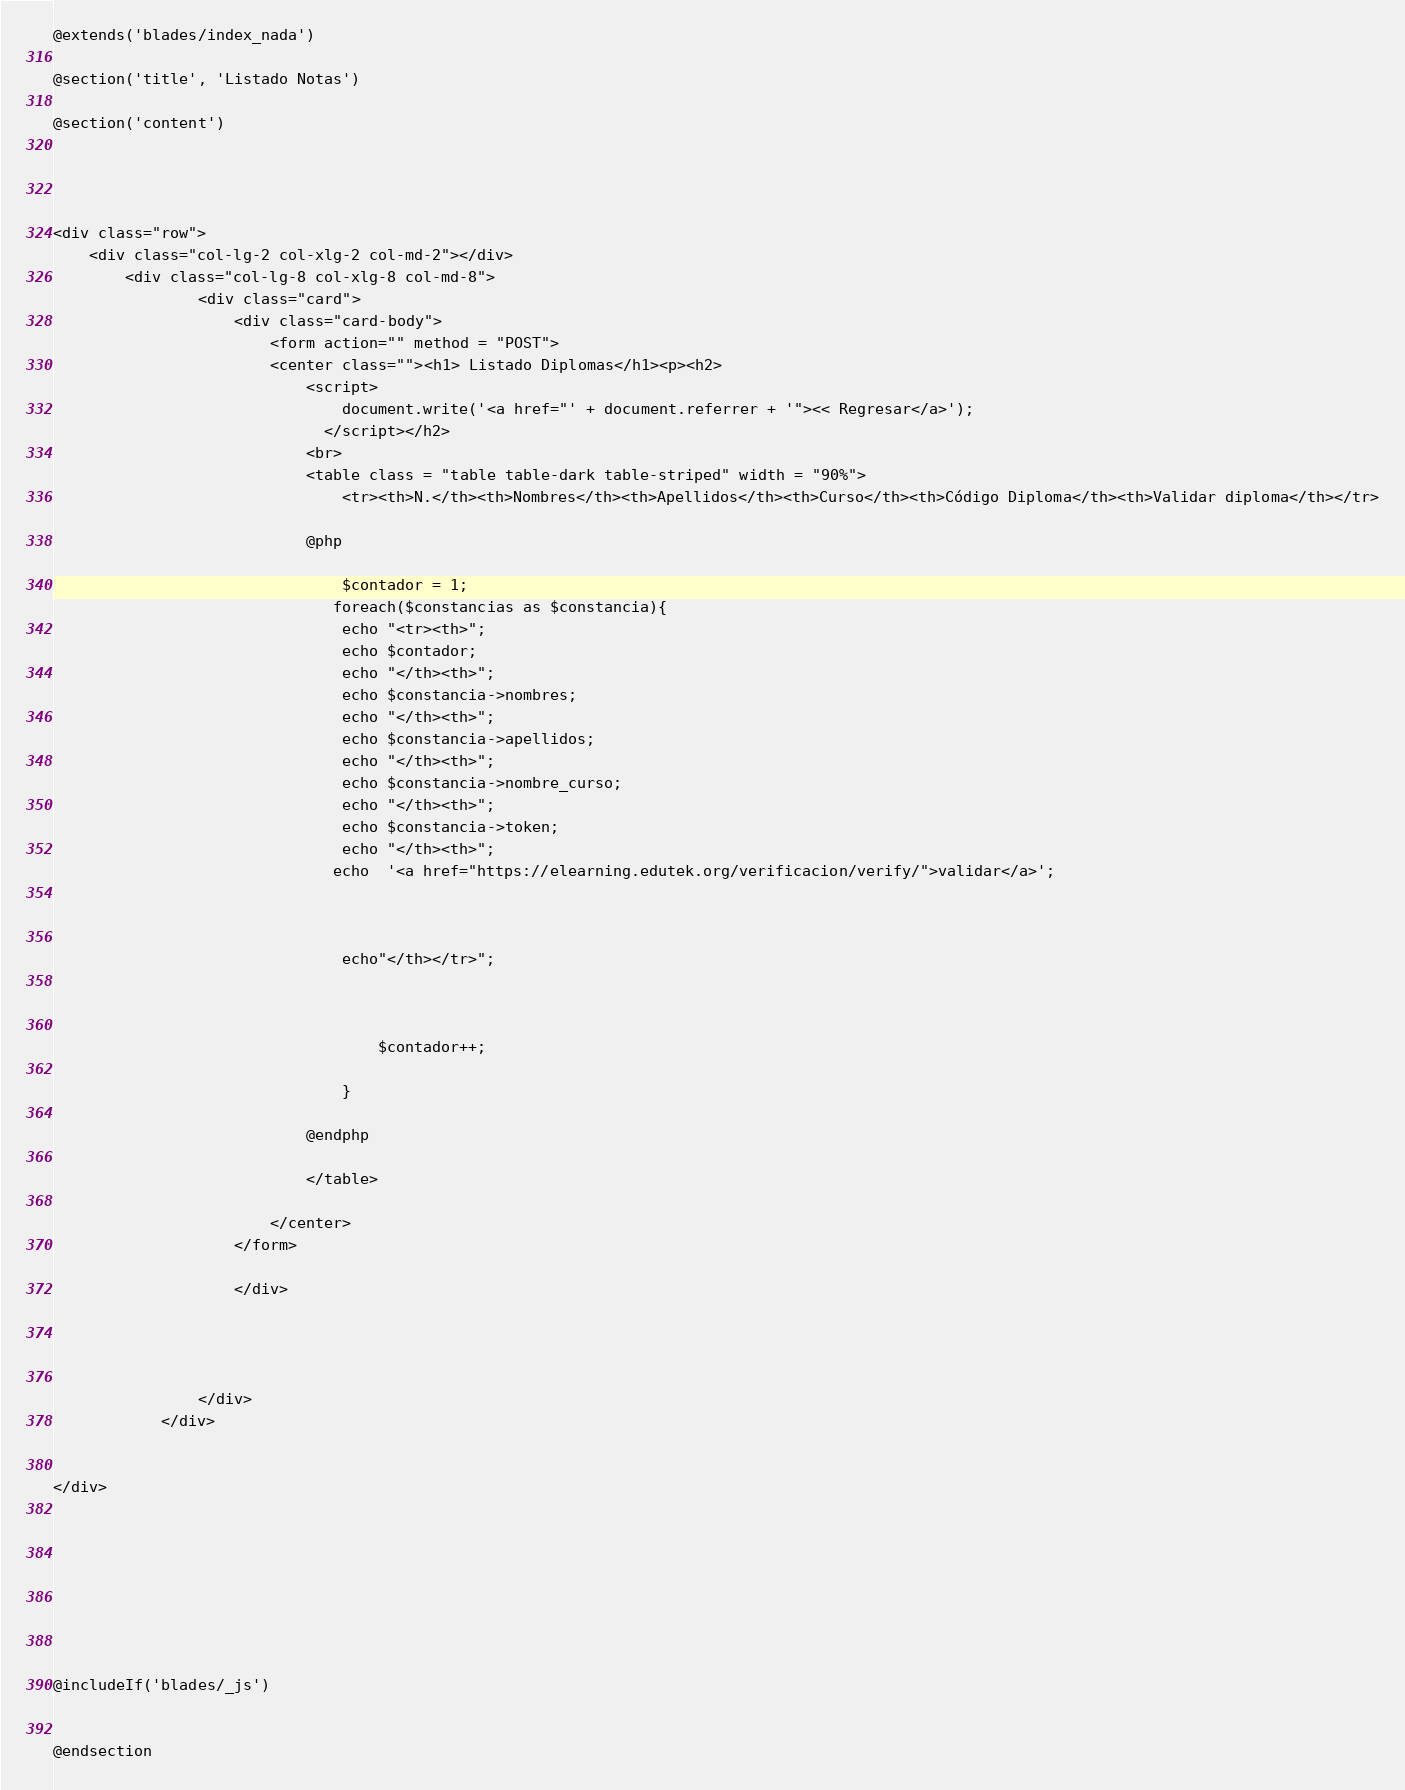Convert code to text. <code><loc_0><loc_0><loc_500><loc_500><_PHP_>@extends('blades/index_nada')

@section('title', 'Listado Notas')

@section('content')




<div class="row">
    <div class="col-lg-2 col-xlg-2 col-md-2"></div>
        <div class="col-lg-8 col-xlg-8 col-md-8">
                <div class="card">
                    <div class="card-body">
                        <form action="" method = "POST">
                        <center class=""><h1> Listado Diplomas</h1><p><h2>
                            <script>
                                document.write('<a href="' + document.referrer + '"><< Regresar</a>');
                              </script></h2>
                            <br>
                            <table class = "table table-dark table-striped" width = "90%">
                                <tr><th>N.</th><th>Nombres</th><th>Apellidos</th><th>Curso</th><th>Código Diploma</th><th>Validar diploma</th></tr>
                             
                            @php
                               
                                $contador = 1;
                               foreach($constancias as $constancia){
                                echo "<tr><th>";      
                                echo $contador;
                                echo "</th><th>";   
                                echo $constancia->nombres;
                                echo "</th><th>";
                                echo $constancia->apellidos;
                                echo "</th><th>";
                                echo $constancia->nombre_curso;
                                echo "</th><th>";
                                echo $constancia->token;
                                echo "</th><th>";
                               echo  '<a href="https://elearning.edutek.org/verificacion/verify/">validar</a>';
                                
                                    
                                   
                                echo"</th></tr>";


                                
                                    $contador++;
                        
                                }
                                
                            @endphp 
                            
                            </table>
                   
                        </center> 
                    </form>

                    </div>
                    
                    
                    
                    
                </div>
            </div>    
 
    
</div>
    
    
     

        



@includeIf('blades/_js')


@endsection</code> 